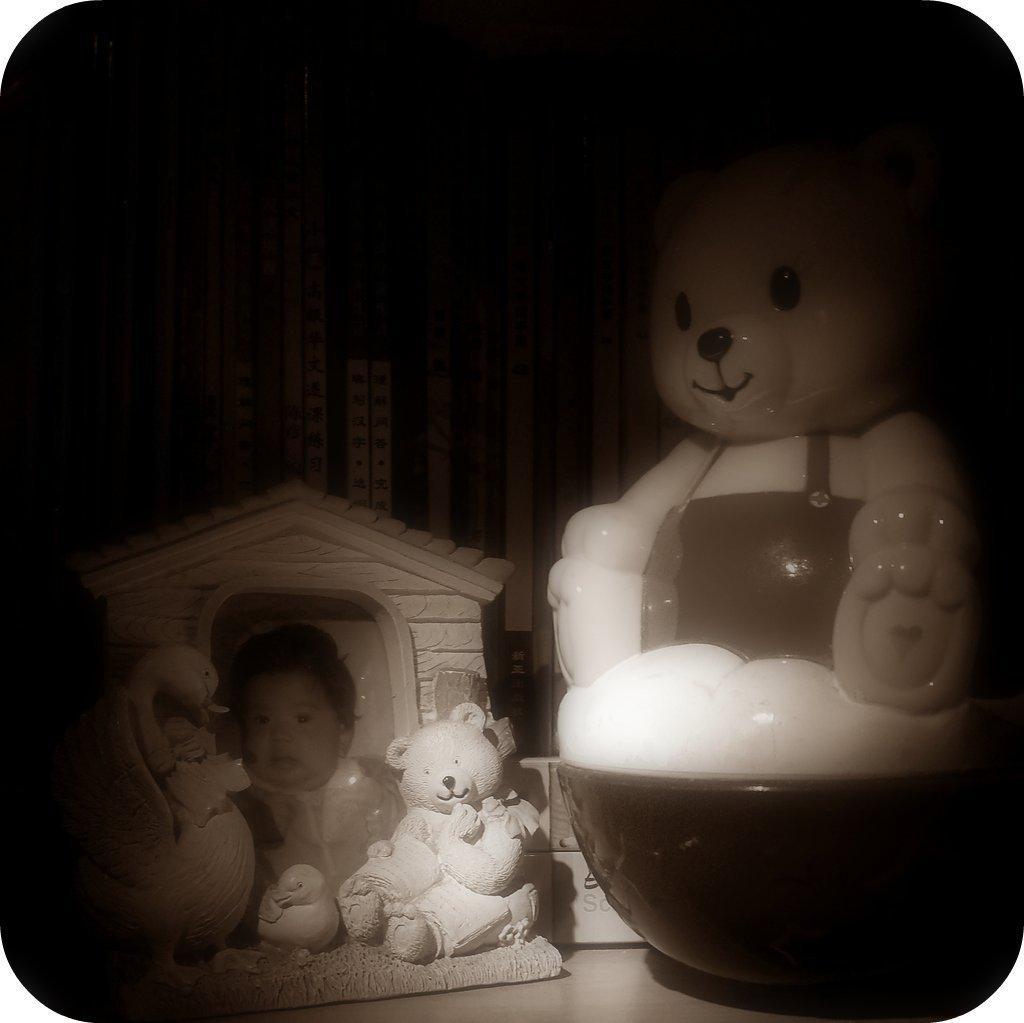In one or two sentences, can you explain what this image depicts? Here in this picture we can see a photo frame and a couple of toys present over there. 